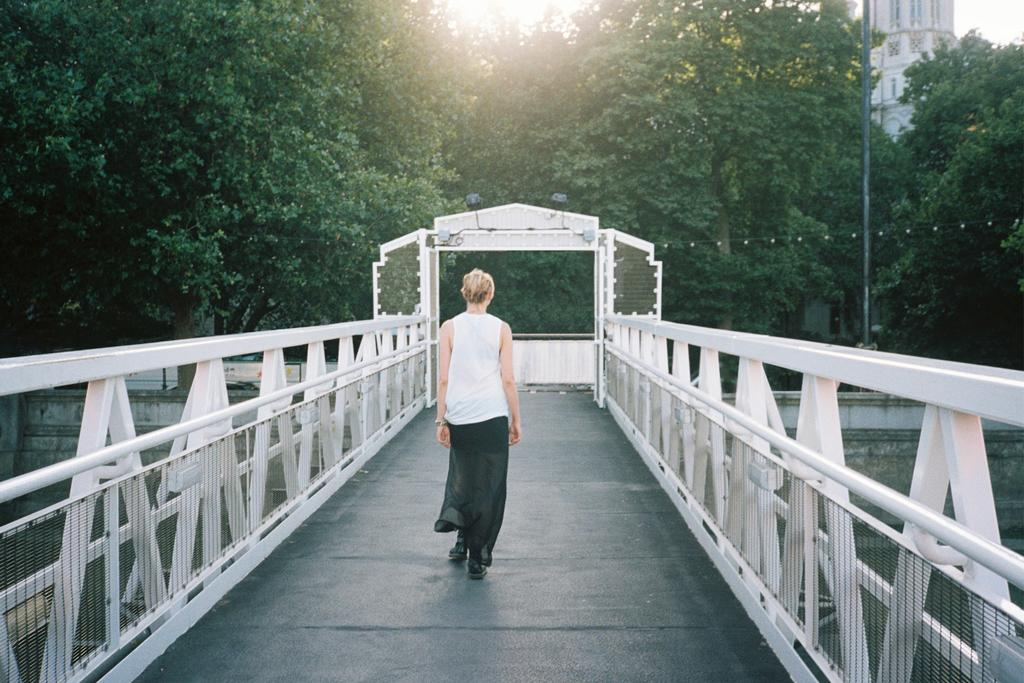What is the person in the image doing? The person is walking on a bridge in the image. What can be seen in the background of the image? There are trees, a pole, buildings, and the sky visible in the background of the image. What time of day might the image have been taken? The image was likely taken during the day, as the sky is visible and not dark. What organization does the person's friend belong to in the image? There is no friend or organization mentioned or visible in the image. 